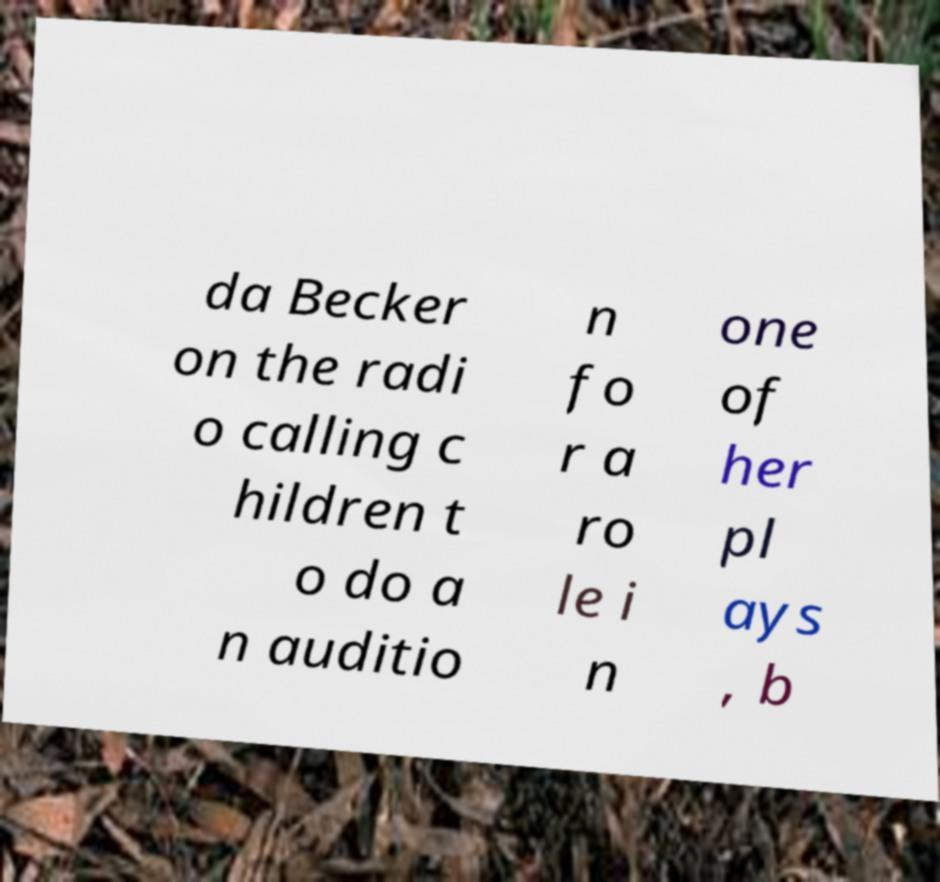Could you extract and type out the text from this image? da Becker on the radi o calling c hildren t o do a n auditio n fo r a ro le i n one of her pl ays , b 